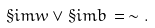<formula> <loc_0><loc_0><loc_500><loc_500>\S i m { w } \vee \S i m { b } \, = \, \sim .</formula> 